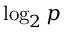Convert formula to latex. <formula><loc_0><loc_0><loc_500><loc_500>\log _ { 2 } p</formula> 